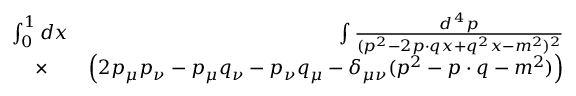Convert formula to latex. <formula><loc_0><loc_0><loc_500><loc_500>\begin{array} { r l r } { \int _ { 0 } ^ { 1 } d x \, } & { \int { \frac { d ^ { \, 4 } p } { ( p ^ { 2 } - 2 p \cdot q x + q ^ { 2 } x - m ^ { 2 } ) ^ { 2 } } } } \\ { \times } & { \left ( 2 p _ { \mu } p _ { \nu } - p _ { \mu } q _ { \nu } - p _ { \nu } q _ { \mu } - \delta _ { \mu \nu } ( p ^ { 2 } - p \cdot q - m ^ { 2 } ) \right ) } \end{array}</formula> 